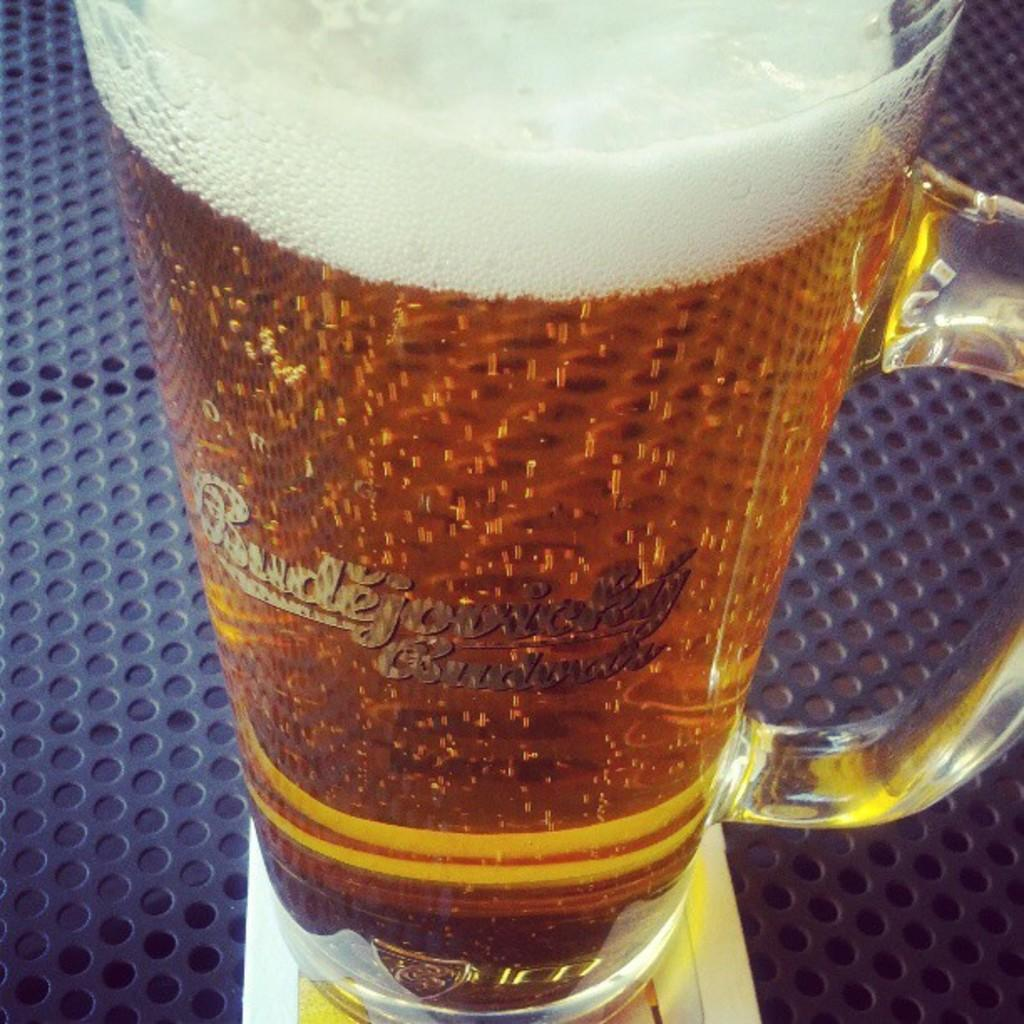<image>
Share a concise interpretation of the image provided. A close up of a mug of beer with the word Budweiser under a foreign word. 